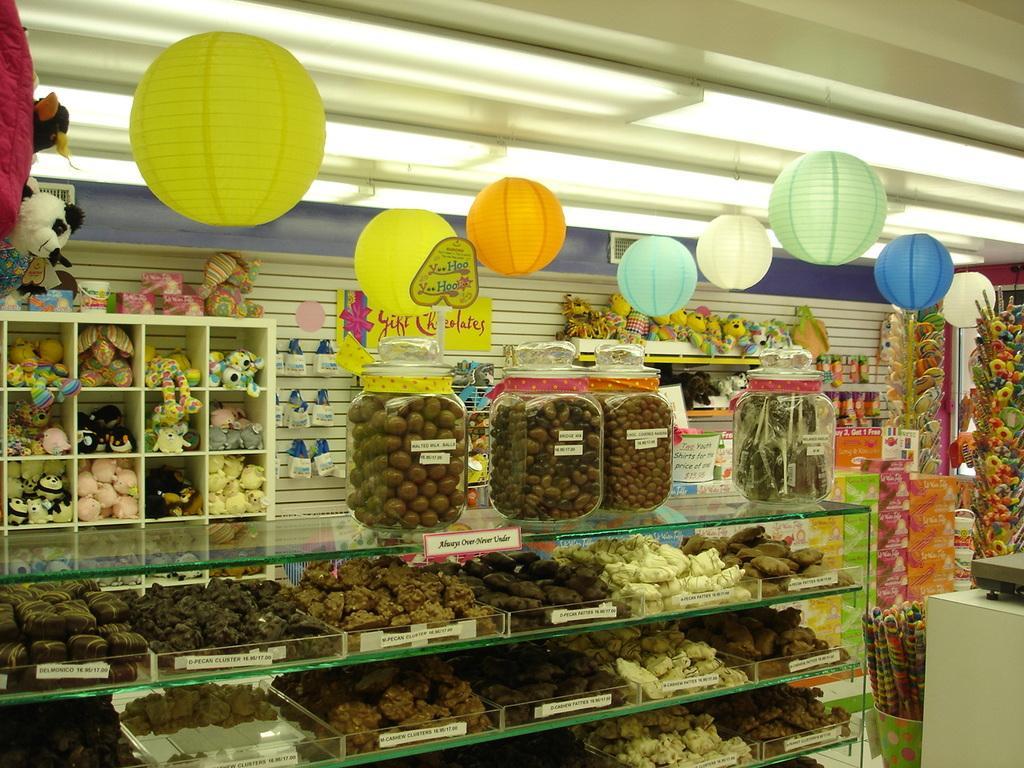Describe this image in one or two sentences. In this image we can see group of food items in the racks. On the tracks we can see a food item in the bottles. Behind the racks we can see group of toys on the racks and a wall. In the bottom right we can see a table and there is an object on the table. At the top we can see roof, lights and circular objects. 